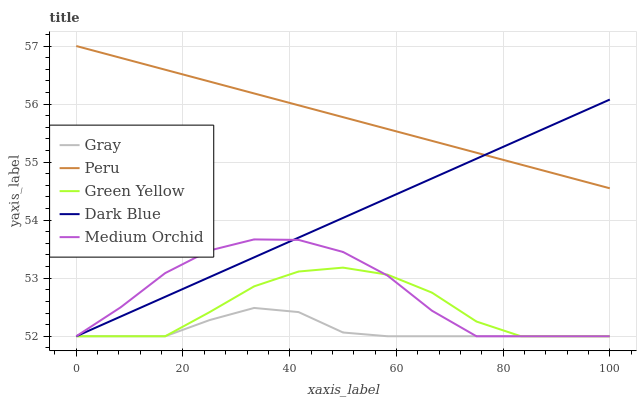Does Gray have the minimum area under the curve?
Answer yes or no. Yes. Does Peru have the maximum area under the curve?
Answer yes or no. Yes. Does Medium Orchid have the minimum area under the curve?
Answer yes or no. No. Does Medium Orchid have the maximum area under the curve?
Answer yes or no. No. Is Dark Blue the smoothest?
Answer yes or no. Yes. Is Medium Orchid the roughest?
Answer yes or no. Yes. Is Green Yellow the smoothest?
Answer yes or no. No. Is Green Yellow the roughest?
Answer yes or no. No. Does Gray have the lowest value?
Answer yes or no. Yes. Does Peru have the lowest value?
Answer yes or no. No. Does Peru have the highest value?
Answer yes or no. Yes. Does Medium Orchid have the highest value?
Answer yes or no. No. Is Medium Orchid less than Peru?
Answer yes or no. Yes. Is Peru greater than Green Yellow?
Answer yes or no. Yes. Does Medium Orchid intersect Dark Blue?
Answer yes or no. Yes. Is Medium Orchid less than Dark Blue?
Answer yes or no. No. Is Medium Orchid greater than Dark Blue?
Answer yes or no. No. Does Medium Orchid intersect Peru?
Answer yes or no. No. 